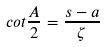Convert formula to latex. <formula><loc_0><loc_0><loc_500><loc_500>c o t \frac { A } { 2 } = \frac { s - a } { \zeta }</formula> 